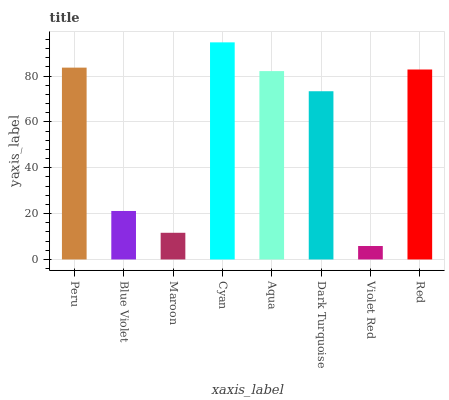Is Violet Red the minimum?
Answer yes or no. Yes. Is Cyan the maximum?
Answer yes or no. Yes. Is Blue Violet the minimum?
Answer yes or no. No. Is Blue Violet the maximum?
Answer yes or no. No. Is Peru greater than Blue Violet?
Answer yes or no. Yes. Is Blue Violet less than Peru?
Answer yes or no. Yes. Is Blue Violet greater than Peru?
Answer yes or no. No. Is Peru less than Blue Violet?
Answer yes or no. No. Is Aqua the high median?
Answer yes or no. Yes. Is Dark Turquoise the low median?
Answer yes or no. Yes. Is Violet Red the high median?
Answer yes or no. No. Is Cyan the low median?
Answer yes or no. No. 